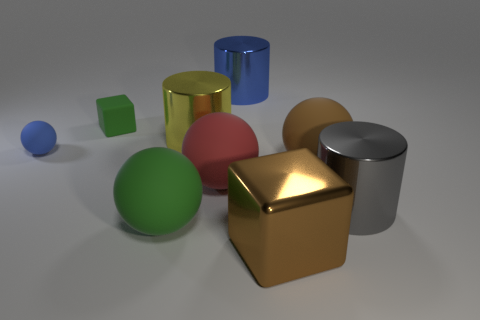Do the tiny thing to the right of the small blue object and the large rubber object that is to the left of the yellow cylinder have the same color?
Keep it short and to the point. Yes. How many other things are there of the same shape as the large brown matte object?
Provide a short and direct response. 3. Is the number of large objects that are in front of the large brown block the same as the number of green matte things that are in front of the green ball?
Make the answer very short. Yes. Is the big brown object that is in front of the green ball made of the same material as the green thing that is behind the large red object?
Make the answer very short. No. What number of other objects are there of the same size as the matte cube?
Offer a very short reply. 1. What number of objects are blue spheres or big shiny things that are on the left side of the big brown matte sphere?
Offer a very short reply. 4. Is the number of spheres that are in front of the tiny blue rubber sphere the same as the number of big brown blocks?
Keep it short and to the point. No. What shape is the large yellow thing that is the same material as the gray object?
Offer a very short reply. Cylinder. Are there any objects of the same color as the large metallic block?
Keep it short and to the point. Yes. What number of metallic things are either blue cylinders or big gray spheres?
Give a very brief answer. 1. 